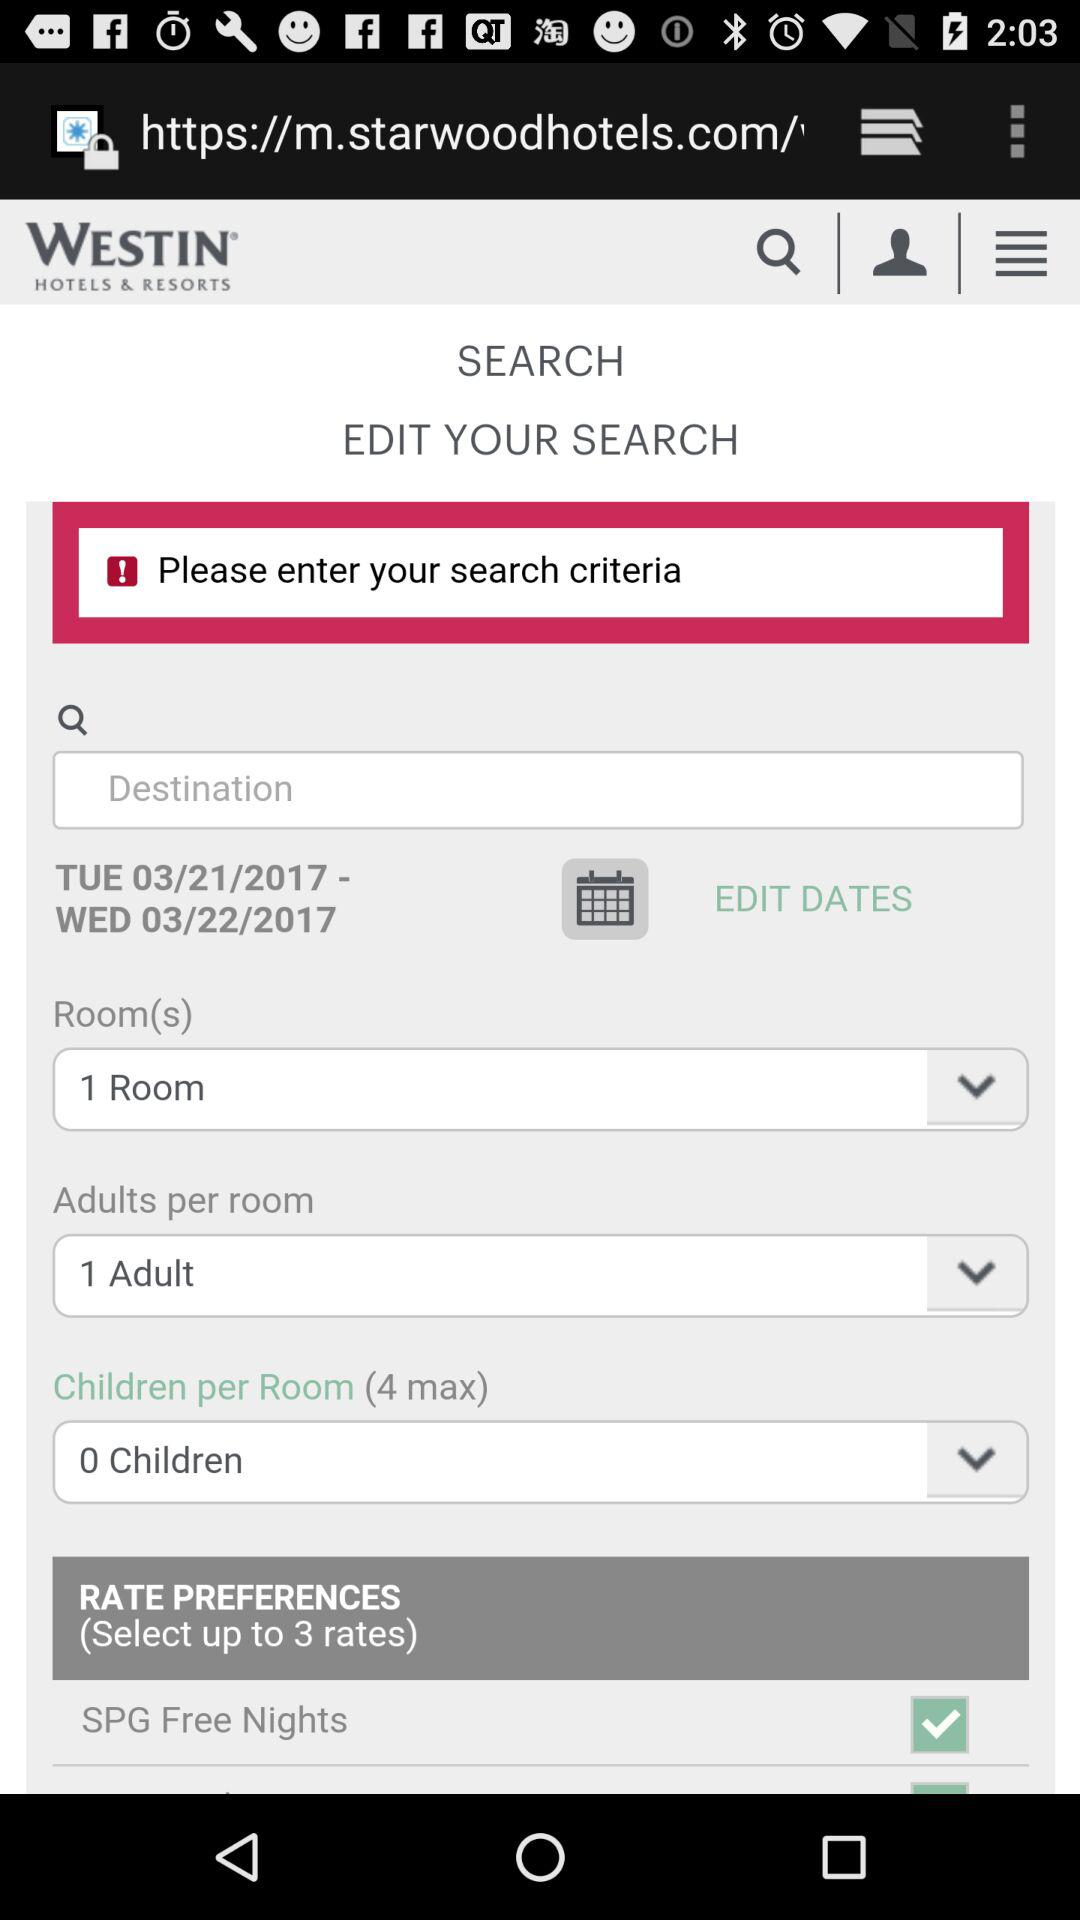How many more adults per room are there than children per room?
Answer the question using a single word or phrase. 1 